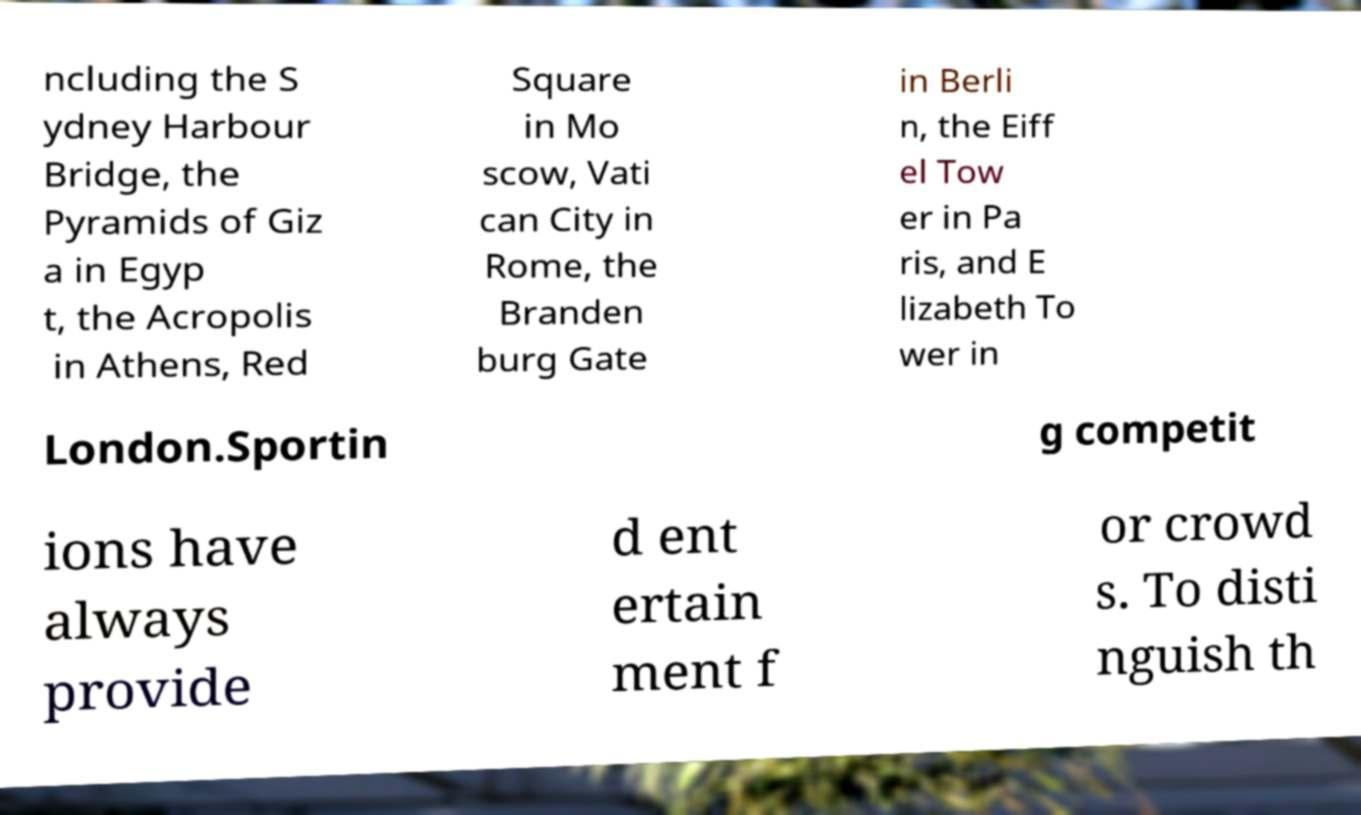For documentation purposes, I need the text within this image transcribed. Could you provide that? ncluding the S ydney Harbour Bridge, the Pyramids of Giz a in Egyp t, the Acropolis in Athens, Red Square in Mo scow, Vati can City in Rome, the Branden burg Gate in Berli n, the Eiff el Tow er in Pa ris, and E lizabeth To wer in London.Sportin g competit ions have always provide d ent ertain ment f or crowd s. To disti nguish th 